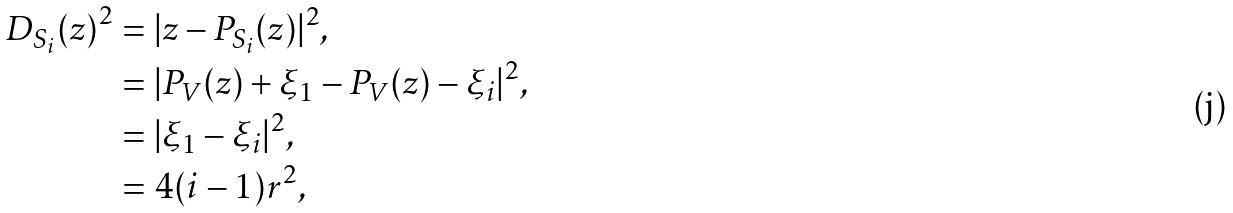Convert formula to latex. <formula><loc_0><loc_0><loc_500><loc_500>{ D _ { S _ { i } } ( z ) } ^ { 2 } & = | z - P _ { S _ { i } } ( z ) | ^ { 2 } , \\ & = | P _ { V } ( z ) + \xi _ { 1 } - P _ { V } ( z ) - \xi _ { i } | ^ { 2 } , \\ & = | \xi _ { 1 } - \xi _ { i } | ^ { 2 } , \\ & = 4 ( i - 1 ) r ^ { 2 } ,</formula> 